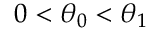<formula> <loc_0><loc_0><loc_500><loc_500>0 < \theta _ { 0 } < \theta _ { 1 }</formula> 